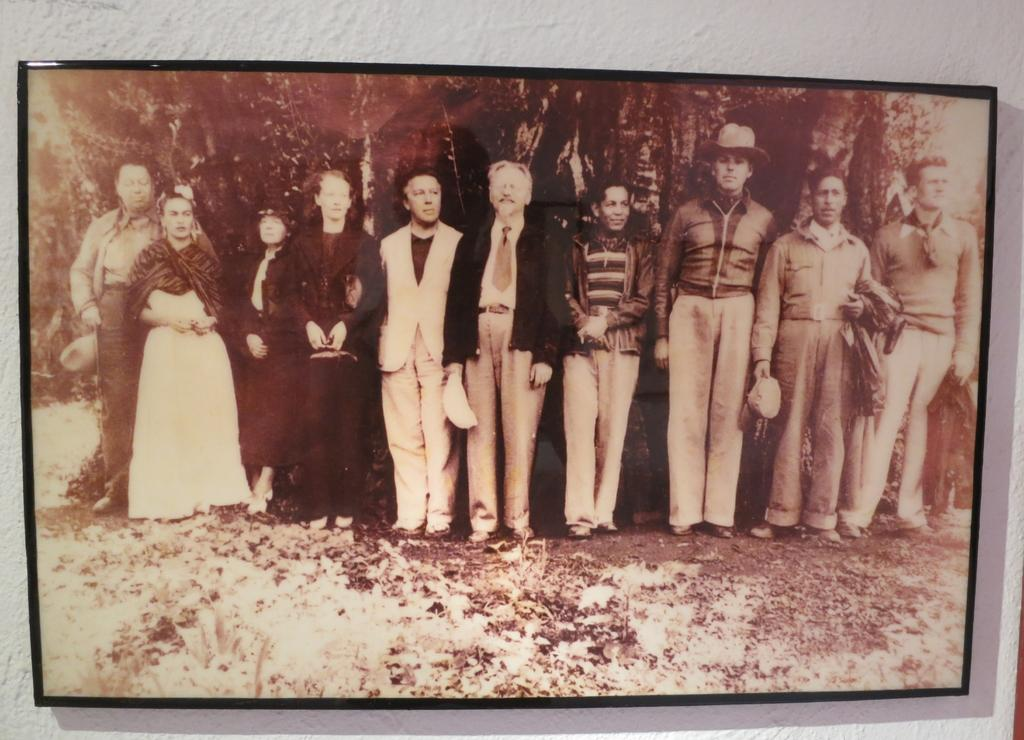What is attached to the wall in the image? There is a photo frame attached to the wall in the image. What can be seen inside the photo frame? People are standing on the ground in the photo frame. What are the people in the photo frame holding? The people in the photo frame are holding objects. What can be seen in the background of the image? There are trees visible in the background of the image. What is the secretary doing in the image? There is no secretary present in the image. 